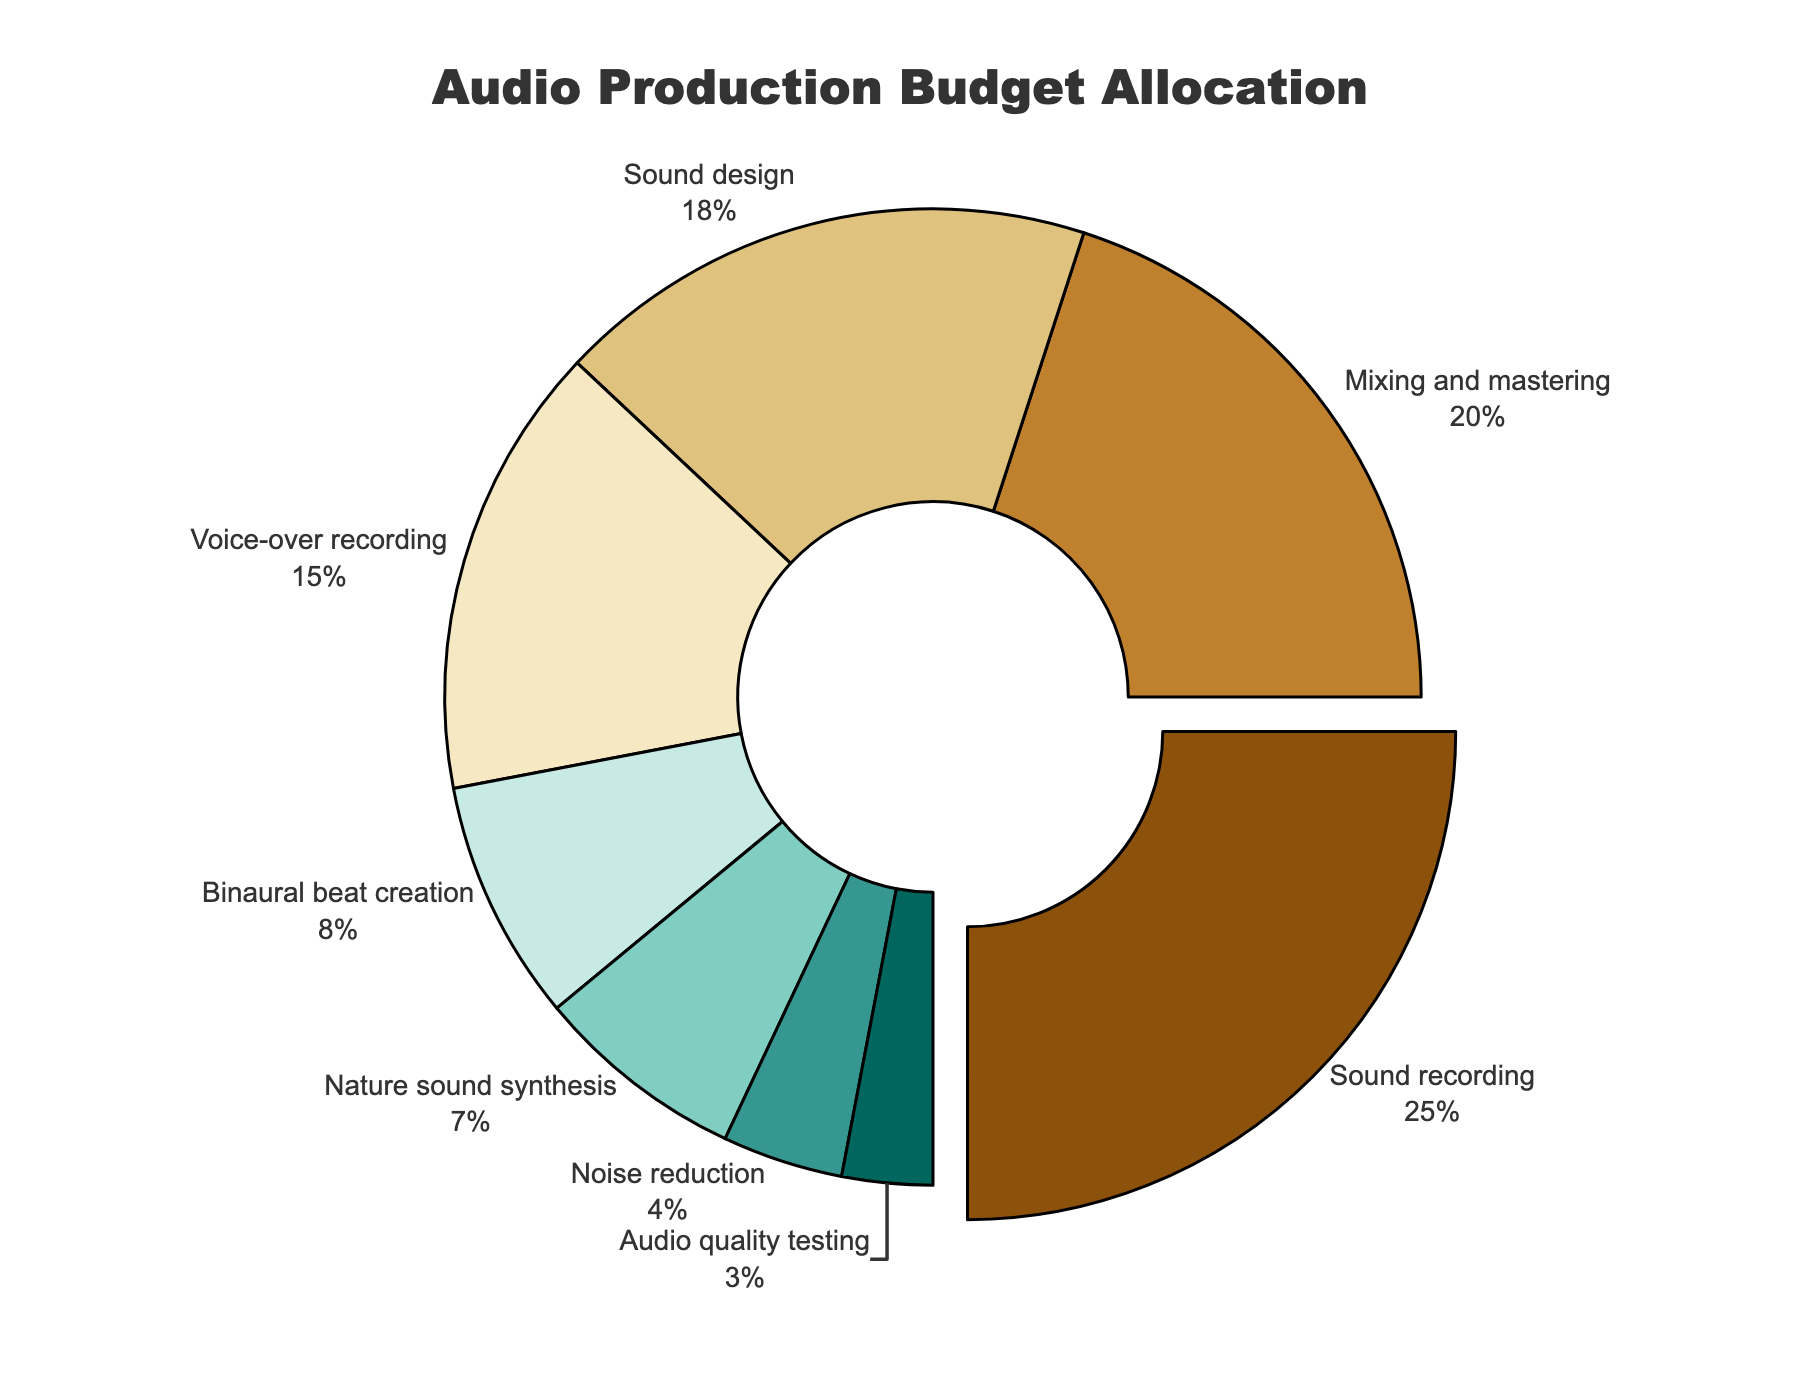What is the largest category in the audio production budget? The largest category can be identified by looking at the percentage values and finding the highest. In this case, "Sound recording" has the highest percentage at 25%.
Answer: Sound recording How much more budget is allocated to Sound design compared to Noise reduction? To find out the difference, subtract the percentage of Noise reduction from Sound design. The values are Sound design (18%) and Noise reduction (4%), so the subtraction is 18% - 4%.
Answer: 14% Which category has the smallest allocation? The smallest allocation can be identified by finding the lowest percentage value in the figure. "Audio quality testing" has the smallest allocation at 3%.
Answer: Audio quality testing Combine the budget percentages for Mixing and mastering, and Nature sound synthesis. What is the total percentage? Add the percentages of Mixing and mastering (20%) and Nature sound synthesis (7%). The total is 20% + 7%.
Answer: 27% What is the median budget category and its percentage? To find the median, list all categories in ascending order of their percentage values: 3, 4, 7, 8, 15, 18, 20, 25. The median is between the 4th and 5th values (8% and 15%), so the median is their average, (8% + 15%) / 2.
Answer: 11.5% Which categories have allocations that are greater than 10%? Look at the percentages and identify those greater than 10%. These categories are Sound recording (25%), Mixing and mastering (20%), Sound design (18%), and Voice-over recording (15%).
Answer: Sound recording, Mixing and mastering, Sound design, Voice-over recording If the budget for Binaural beat creation and Nature sound synthesis were combined, would it exceed the budget for Voice-over recording? Add the percentages for Binaural beat creation (8%) and Nature sound synthesis (7%), then compare the sum to the percentage for Voice-over recording (15%). The sum is 8% + 7% = 15%, which is equal to the budget for Voice-over recording.
Answer: No What is the total percentage allocated to categories with less than 10%? Add the percentages of categories with less than 10%. These are Binaural beat creation (8%), Nature sound synthesis (7%), Noise reduction (4%), and Audio quality testing (3%). The total is 8% + 7% + 4% + 3%.
Answer: 22% Which category's segment is visually pulled out from the pie chart and why? The visual segment pulled out is the one with the highest percentage, which is Sound recording at 25%. The segment is pulled out to emphasize the largest allocation.
Answer: Sound recording 